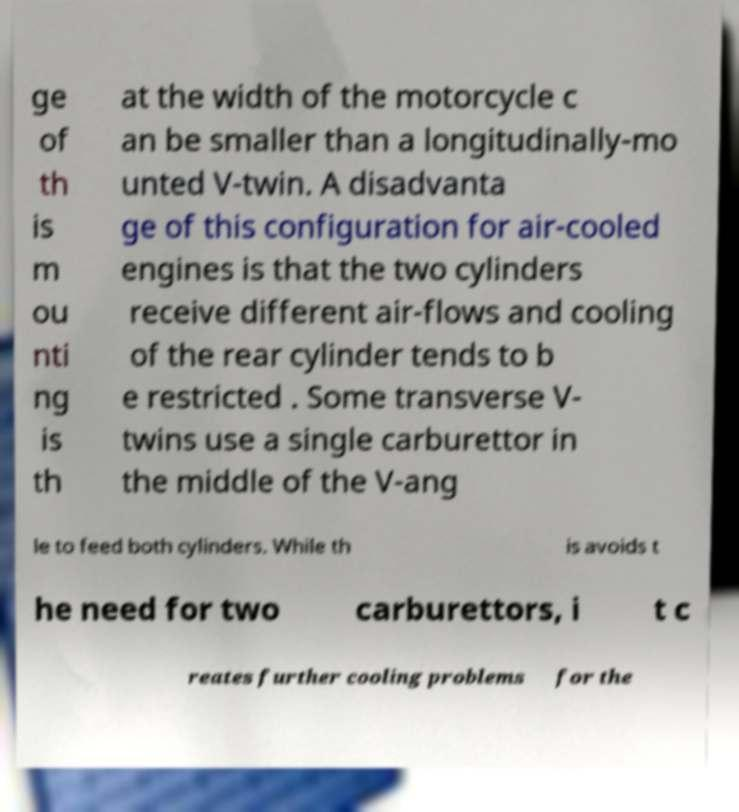Please identify and transcribe the text found in this image. ge of th is m ou nti ng is th at the width of the motorcycle c an be smaller than a longitudinally-mo unted V-twin. A disadvanta ge of this configuration for air-cooled engines is that the two cylinders receive different air-flows and cooling of the rear cylinder tends to b e restricted . Some transverse V- twins use a single carburettor in the middle of the V-ang le to feed both cylinders. While th is avoids t he need for two carburettors, i t c reates further cooling problems for the 